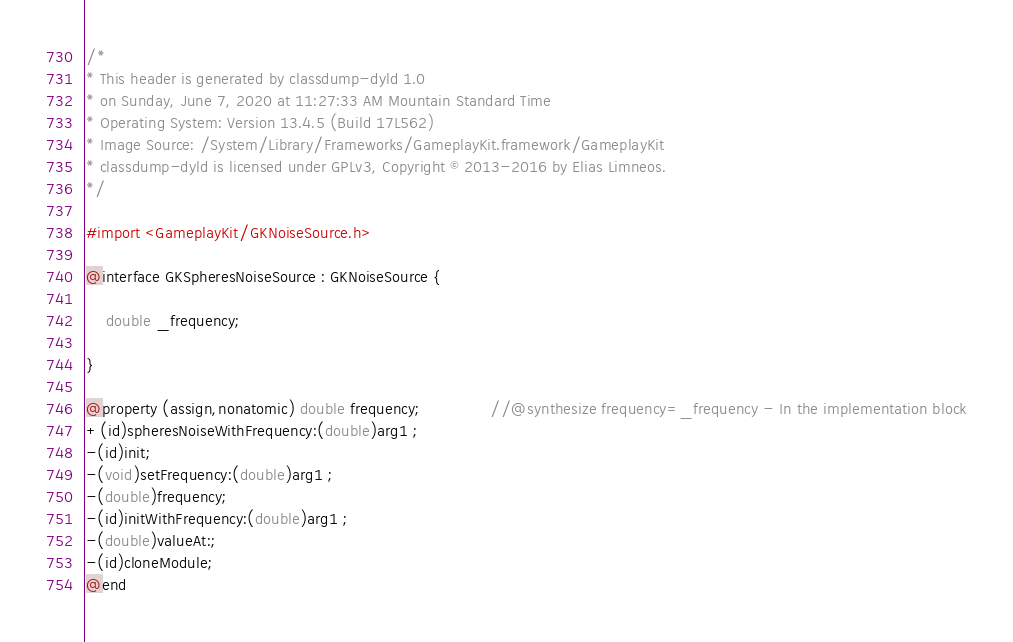<code> <loc_0><loc_0><loc_500><loc_500><_C_>/*
* This header is generated by classdump-dyld 1.0
* on Sunday, June 7, 2020 at 11:27:33 AM Mountain Standard Time
* Operating System: Version 13.4.5 (Build 17L562)
* Image Source: /System/Library/Frameworks/GameplayKit.framework/GameplayKit
* classdump-dyld is licensed under GPLv3, Copyright © 2013-2016 by Elias Limneos.
*/

#import <GameplayKit/GKNoiseSource.h>

@interface GKSpheresNoiseSource : GKNoiseSource {

	double _frequency;

}

@property (assign,nonatomic) double frequency;              //@synthesize frequency=_frequency - In the implementation block
+(id)spheresNoiseWithFrequency:(double)arg1 ;
-(id)init;
-(void)setFrequency:(double)arg1 ;
-(double)frequency;
-(id)initWithFrequency:(double)arg1 ;
-(double)valueAt:;
-(id)cloneModule;
@end

</code> 